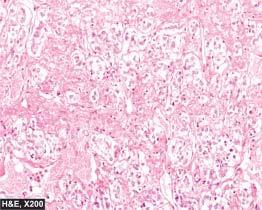what are large, polyhedral and pleomorphic having abundant granular cytoplasm?
Answer the question using a single word or phrase. Tumour cells 